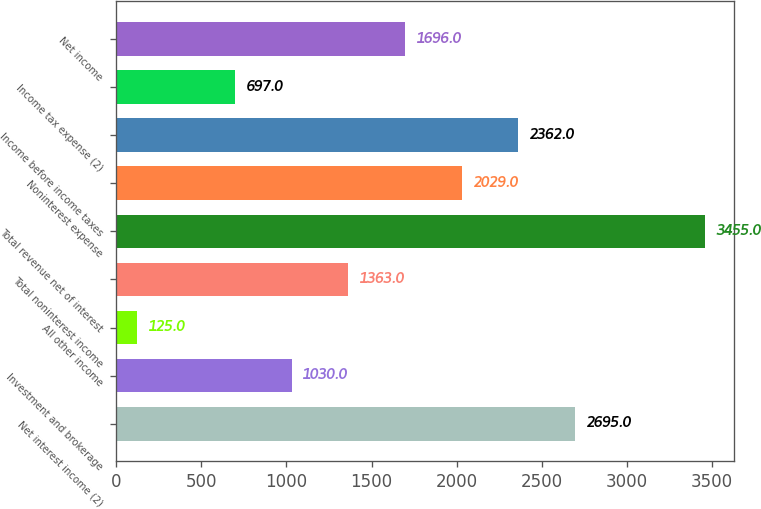Convert chart to OTSL. <chart><loc_0><loc_0><loc_500><loc_500><bar_chart><fcel>Net interest income (2)<fcel>Investment and brokerage<fcel>All other income<fcel>Total noninterest income<fcel>Total revenue net of interest<fcel>Noninterest expense<fcel>Income before income taxes<fcel>Income tax expense (2)<fcel>Net income<nl><fcel>2695<fcel>1030<fcel>125<fcel>1363<fcel>3455<fcel>2029<fcel>2362<fcel>697<fcel>1696<nl></chart> 